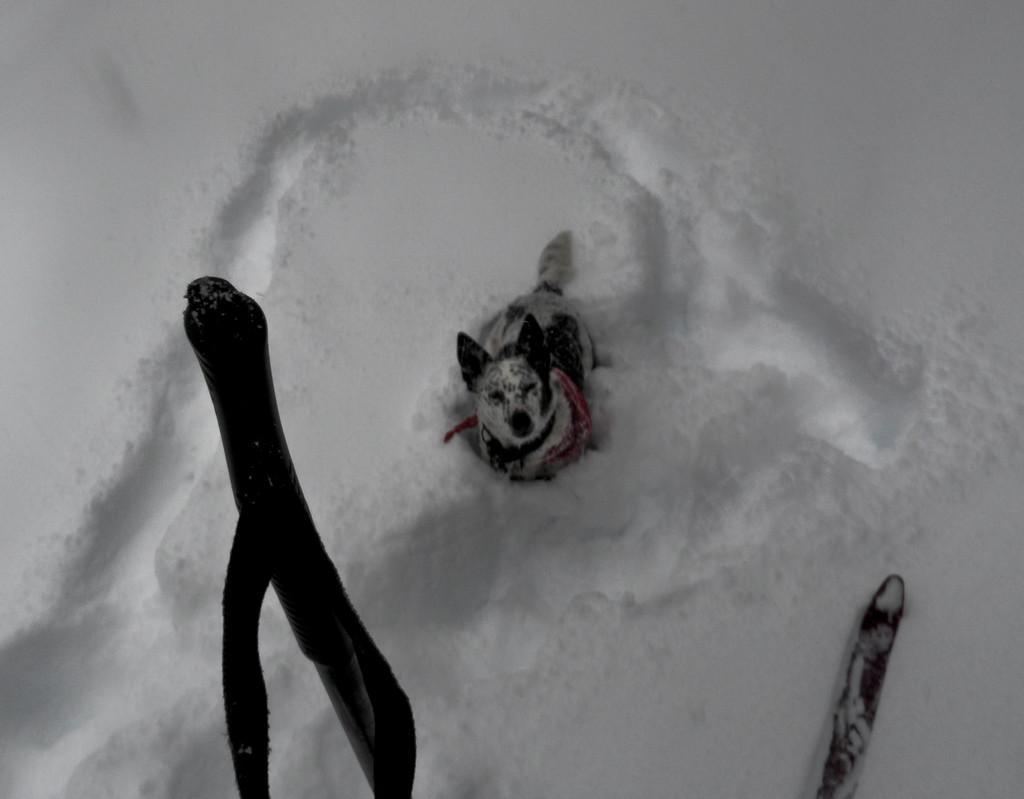Could you give a brief overview of what you see in this image? In this picture, we can see the ground covered with snow, we can see the dog and some objects in the bottom side of the picture. 